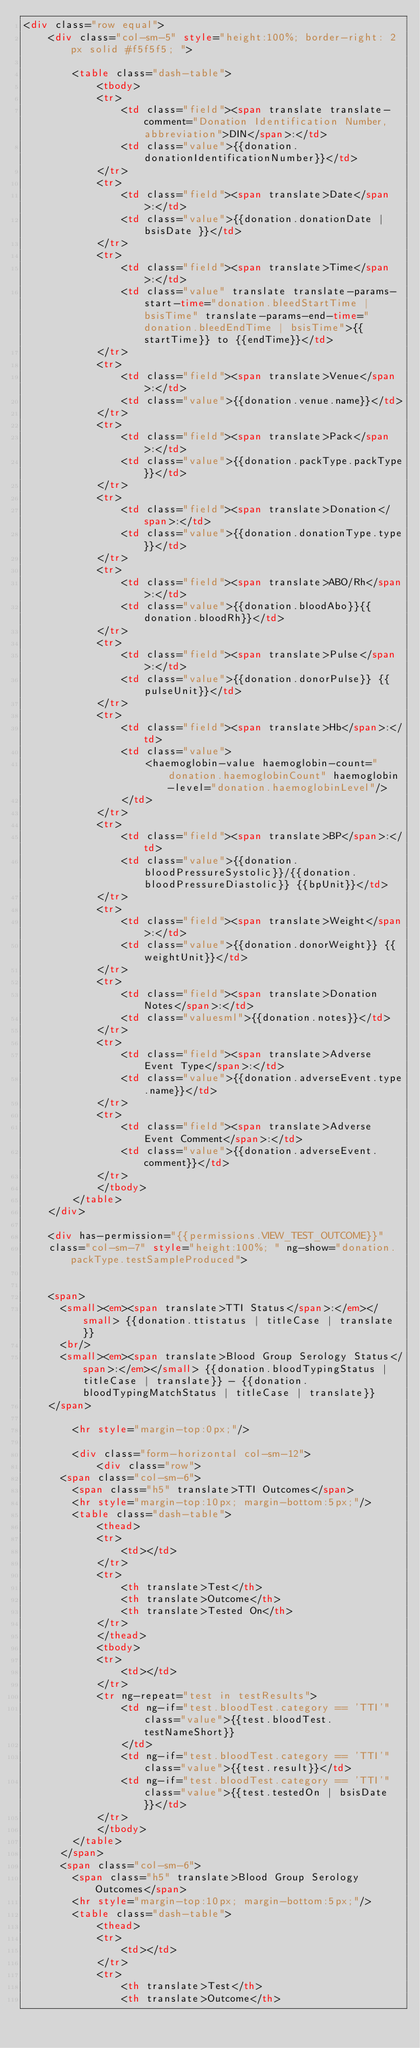Convert code to text. <code><loc_0><loc_0><loc_500><loc_500><_HTML_><div class="row equal">
    <div class="col-sm-5" style="height:100%; border-right: 2px solid #f5f5f5; ">

        <table class="dash-table">
            <tbody>
            <tr>
                <td class="field"><span translate translate-comment="Donation Identification Number, abbreviation">DIN</span>:</td>
                <td class="value">{{donation.donationIdentificationNumber}}</td>
            </tr>
            <tr>
                <td class="field"><span translate>Date</span>:</td>
                <td class="value">{{donation.donationDate | bsisDate }}</td>
            </tr>
            <tr>
                <td class="field"><span translate>Time</span>:</td>
                <td class="value" translate translate-params-start-time="donation.bleedStartTime | bsisTime" translate-params-end-time="donation.bleedEndTime | bsisTime">{{startTime}} to {{endTime}}</td>
            </tr>
            <tr>
                <td class="field"><span translate>Venue</span>:</td>
                <td class="value">{{donation.venue.name}}</td>
            </tr>
            <tr>
                <td class="field"><span translate>Pack</span>:</td>
                <td class="value">{{donation.packType.packType}}</td>
            </tr>
            <tr>
                <td class="field"><span translate>Donation</span>:</td>
                <td class="value">{{donation.donationType.type}}</td>
            </tr>
            <tr>
                <td class="field"><span translate>ABO/Rh</span>:</td>
                <td class="value">{{donation.bloodAbo}}{{donation.bloodRh}}</td>
            </tr>
            <tr>
                <td class="field"><span translate>Pulse</span>:</td>
                <td class="value">{{donation.donorPulse}} {{pulseUnit}}</td>
            </tr>
            <tr>
                <td class="field"><span translate>Hb</span>:</td>
                <td class="value">
                    <haemoglobin-value haemoglobin-count="donation.haemoglobinCount" haemoglobin-level="donation.haemoglobinLevel"/>
                </td>
            </tr>
            <tr>
                <td class="field"><span translate>BP</span>:</td>
                <td class="value">{{donation.bloodPressureSystolic}}/{{donation.bloodPressureDiastolic}} {{bpUnit}}</td>
            </tr>
            <tr>
                <td class="field"><span translate>Weight</span>:</td>
                <td class="value">{{donation.donorWeight}} {{weightUnit}}</td>
            </tr>
            <tr>
                <td class="field"><span translate>Donation Notes</span>:</td>
                <td class="valuesml">{{donation.notes}}</td>
            </tr>
            <tr>
                <td class="field"><span translate>Adverse Event Type</span>:</td>
                <td class="value">{{donation.adverseEvent.type.name}}</td>
            </tr>
            <tr>
                <td class="field"><span translate>Adverse Event Comment</span>:</td>
                <td class="value">{{donation.adverseEvent.comment}}</td>
            </tr>
            </tbody>
        </table>
    </div>

    <div has-permission="{{permissions.VIEW_TEST_OUTCOME}}"
    class="col-sm-7" style="height:100%; " ng-show="donation.packType.testSampleProduced">


    <span>
      <small><em><span translate>TTI Status</span>:</em></small> {{donation.ttistatus | titleCase | translate}}
      <br/>
      <small><em><span translate>Blood Group Serology Status</span>:</em></small> {{donation.bloodTypingStatus | titleCase | translate}} - {{donation.bloodTypingMatchStatus | titleCase | translate}}
    </span>

        <hr style="margin-top:0px;"/>

        <div class="form-horizontal col-sm-12">
            <div class="row">
      <span class="col-sm-6">
        <span class="h5" translate>TTI Outcomes</span>
        <hr style="margin-top:10px; margin-bottom:5px;"/>
        <table class="dash-table">
            <thead>
            <tr>
                <td></td>
            </tr>
            <tr>
                <th translate>Test</th>
                <th translate>Outcome</th>
                <th translate>Tested On</th>
            </tr>
            </thead>
            <tbody>
            <tr>
                <td></td>
            </tr>
            <tr ng-repeat="test in testResults">
                <td ng-if="test.bloodTest.category == 'TTI'" class="value">{{test.bloodTest.testNameShort}}
                </td>
                <td ng-if="test.bloodTest.category == 'TTI'" class="value">{{test.result}}</td>
                <td ng-if="test.bloodTest.category == 'TTI'" class="value">{{test.testedOn | bsisDate}}</td>
            </tr>
            </tbody>
        </table>
      </span>
      <span class="col-sm-6">
        <span class="h5" translate>Blood Group Serology Outcomes</span>
        <hr style="margin-top:10px; margin-bottom:5px;"/>
        <table class="dash-table">
            <thead>
            <tr>
                <td></td>
            </tr>
            <tr>
                <th translate>Test</th>
                <th translate>Outcome</th></code> 